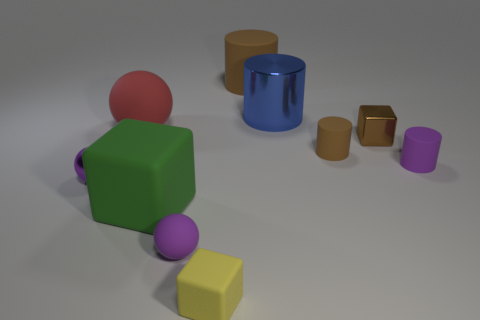Can you compare the shapes and colors visible in the scene? Certainly! The image showcases a variety of shapes, including cubes, cylinders, and spheres, each with its distinct color. You can see a green and a yellow cube, a red sphere, and cylinders in blue, purple, and two shades of gold or brown. The color palette is quite vibrant, adding contrast and interest to the scene. What might be the significance of the different sizes? The varied sizes of the objects could represent a range of perspectives or the idea of growth. It might also suggest a comparative scale or simply be an artistic choice to create a diverse visual experience. 